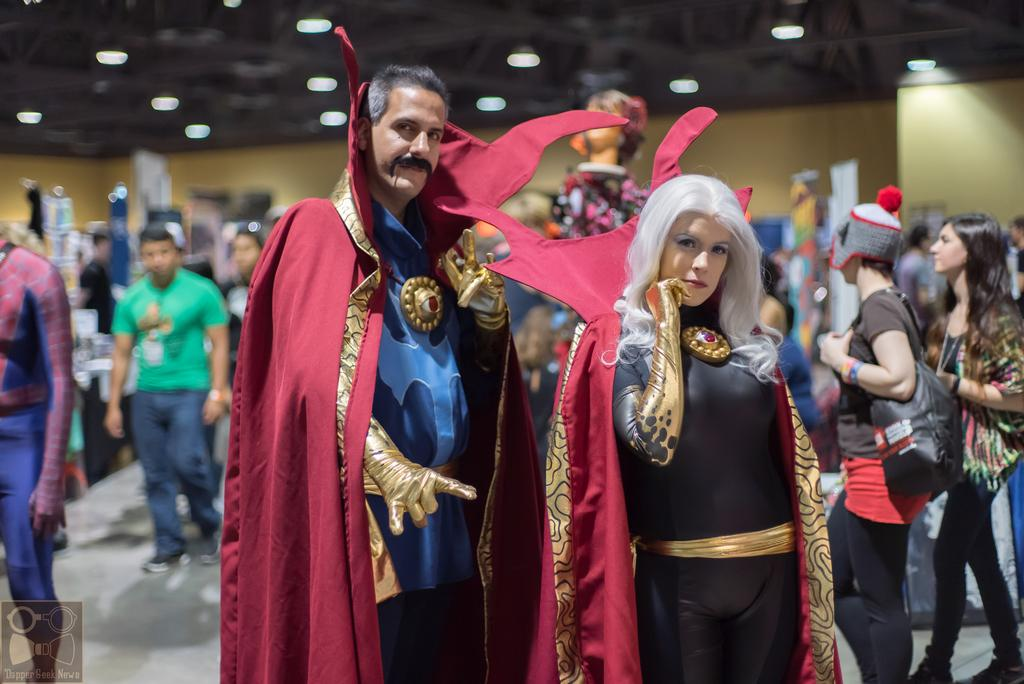Who or what can be seen in the image? There are people in the image. Where are the people located? The people are in a room. What are some of the people wearing? Some people are wearing costumes. What can be seen on the roof in the image? There are lights on the roof in the image. What is the size of the silver scissors in the image? There are no silver scissors present in the image. 